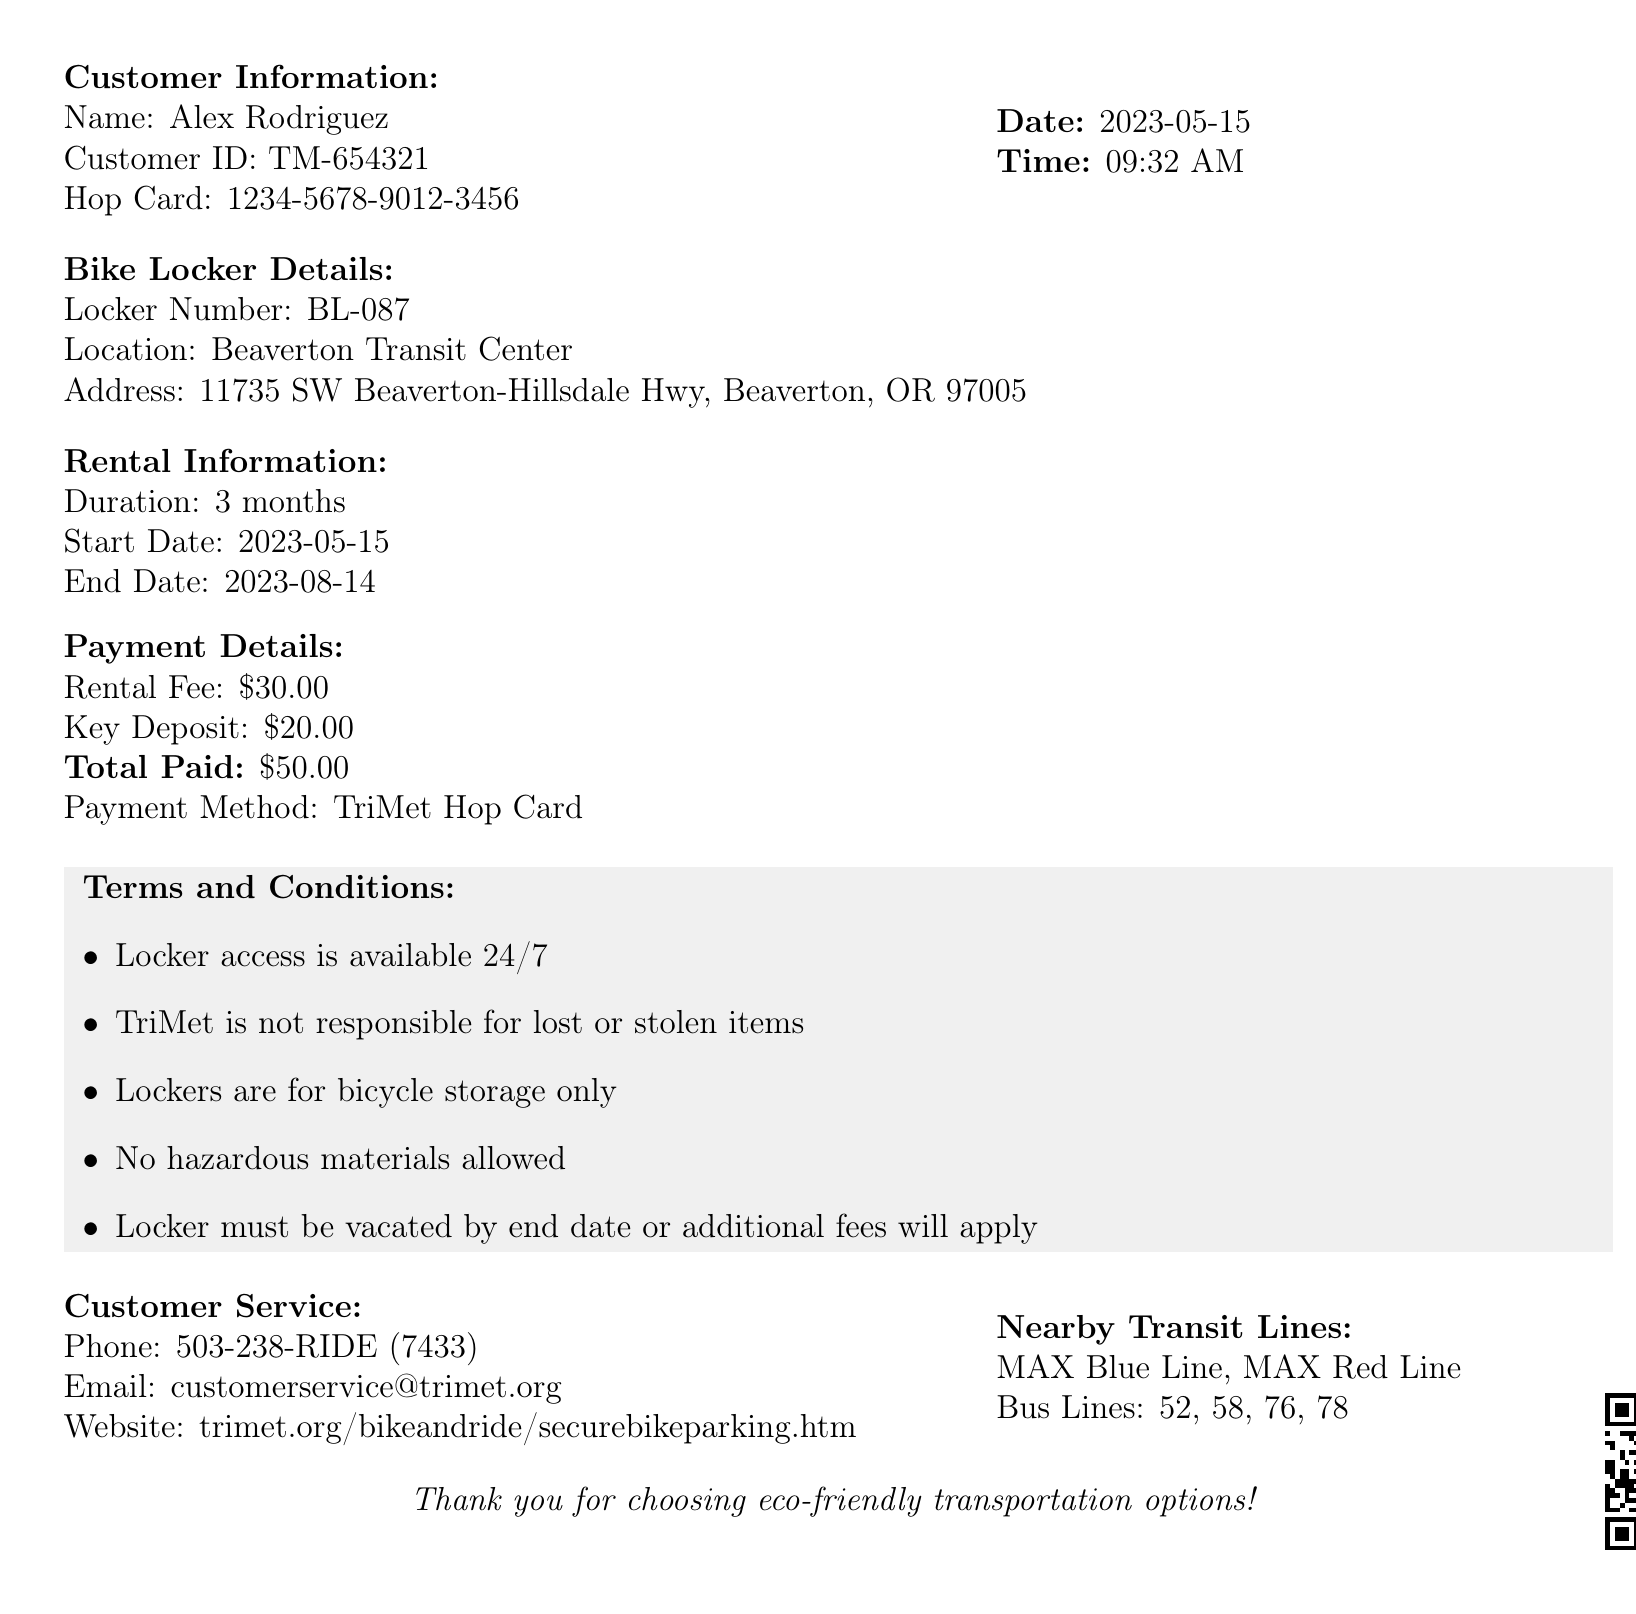What is the receipt number? The receipt number is a unique identifier for the transaction documented in the receipt.
Answer: BL-2023-05789 What is the rental fee? The rental fee is the cost associated with renting the bike locker mentioned in the document.
Answer: $30.00 What is the rental duration? The rental duration indicates how long the bike locker is rented out to the customer.
Answer: 3 months When does the rental period end? The end date specifies the last day access to the bike locker is permitted under the rental agreement.
Answer: 2023-08-14 What location is the bike locker at? The location provides the specific site where the bike locker can be found according to the document.
Answer: Beaverton Transit Center What is the total amount paid? The total amount paid is the complete amount charged to the customer for the rental and deposit.
Answer: $50.00 How many nearby transit lines are listed? This question requires counting the different transit lines mentioned near the locker location.
Answer: 6 What must be vacated by the end date? This question pertains to what the customer is required to clear out of the locker space by the specified end date.
Answer: Locker What payment method was used? The payment method indicates how the customer paid for the bike locker rental detailed in the receipt.
Answer: TriMet Hop Card 